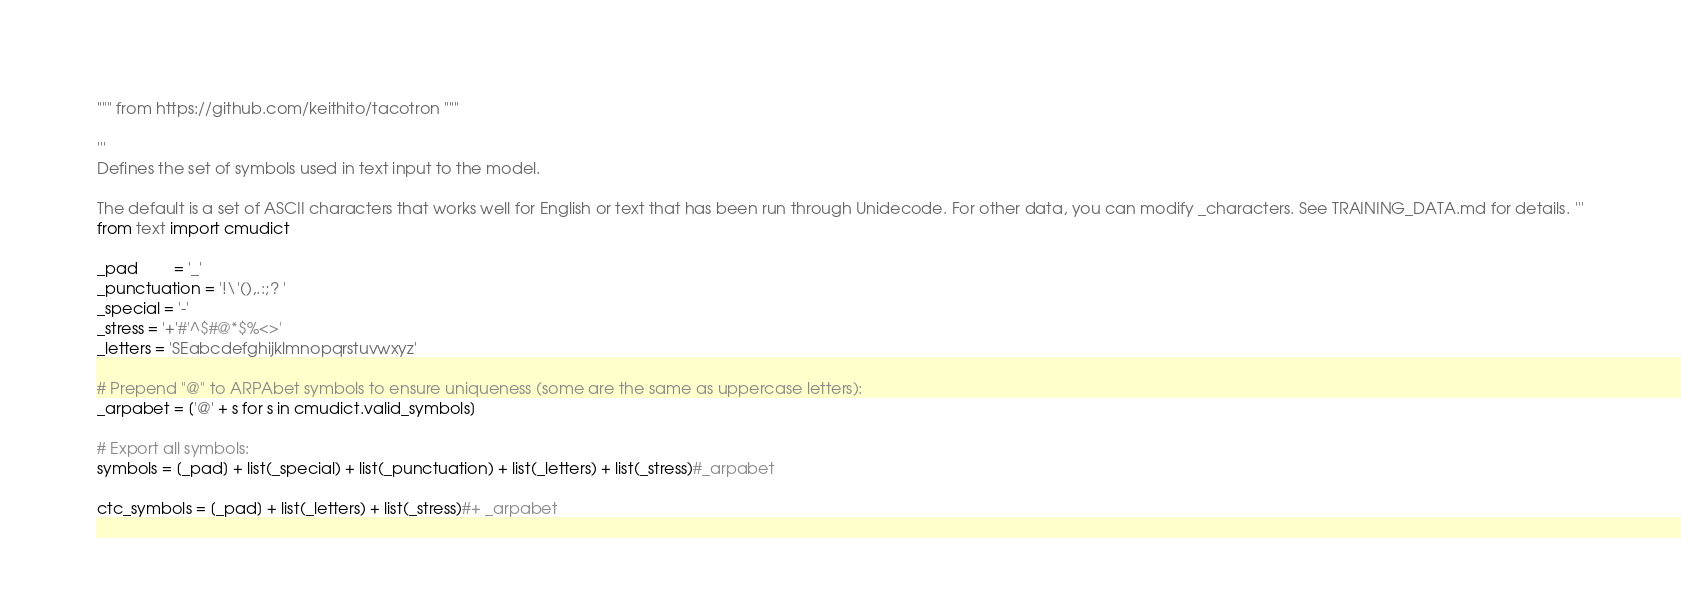<code> <loc_0><loc_0><loc_500><loc_500><_Python_>""" from https://github.com/keithito/tacotron """

'''
Defines the set of symbols used in text input to the model.

The default is a set of ASCII characters that works well for English or text that has been run through Unidecode. For other data, you can modify _characters. See TRAINING_DATA.md for details. '''
from text import cmudict

_pad        = '_'
_punctuation = '!\'(),.:;? '
_special = '-'
_stress = '+'#'^$#@*$%<>'
_letters = 'SEabcdefghijklmnopqrstuvwxyz'

# Prepend "@" to ARPAbet symbols to ensure uniqueness (some are the same as uppercase letters):
_arpabet = ['@' + s for s in cmudict.valid_symbols]

# Export all symbols:
symbols = [_pad] + list(_special) + list(_punctuation) + list(_letters) + list(_stress)#_arpabet

ctc_symbols = [_pad] + list(_letters) + list(_stress)#+ _arpabet</code> 